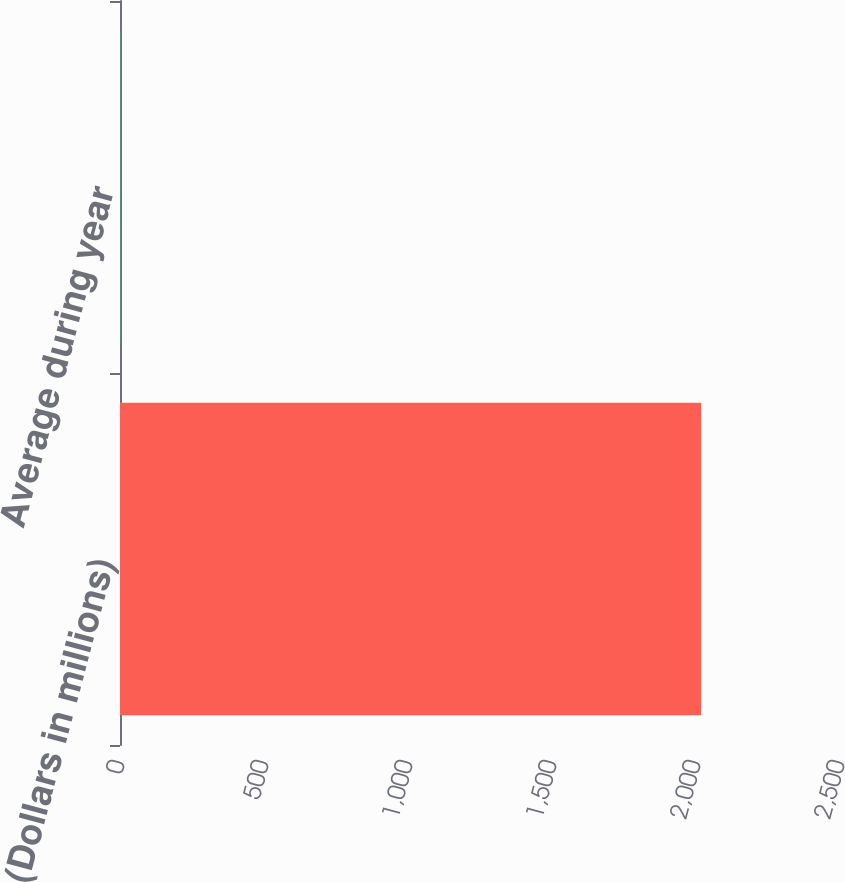Convert chart. <chart><loc_0><loc_0><loc_500><loc_500><bar_chart><fcel>(Dollars in millions)<fcel>Average during year<nl><fcel>2018<fcel>1.26<nl></chart> 